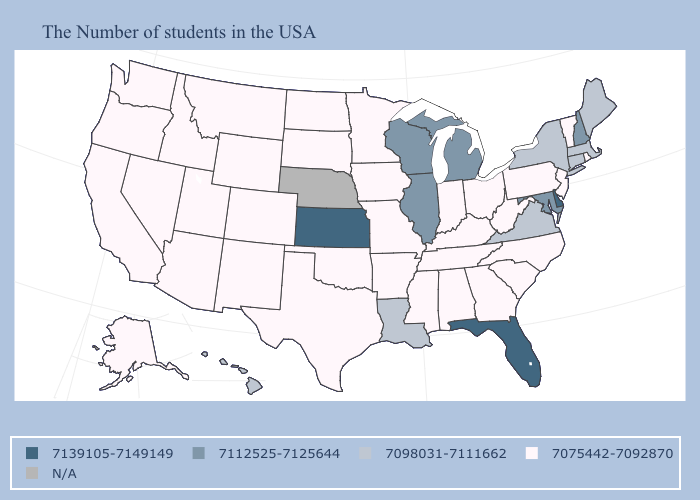Does the first symbol in the legend represent the smallest category?
Give a very brief answer. No. What is the lowest value in states that border Wyoming?
Write a very short answer. 7075442-7092870. Name the states that have a value in the range 7112525-7125644?
Quick response, please. New Hampshire, Maryland, Michigan, Wisconsin, Illinois. Does Iowa have the lowest value in the MidWest?
Short answer required. Yes. What is the lowest value in the USA?
Keep it brief. 7075442-7092870. What is the lowest value in states that border Oregon?
Keep it brief. 7075442-7092870. What is the highest value in the South ?
Short answer required. 7139105-7149149. Name the states that have a value in the range 7139105-7149149?
Quick response, please. Delaware, Florida, Kansas. Name the states that have a value in the range N/A?
Answer briefly. Nebraska. What is the value of Indiana?
Write a very short answer. 7075442-7092870. What is the highest value in states that border Minnesota?
Keep it brief. 7112525-7125644. Which states have the lowest value in the USA?
Write a very short answer. Rhode Island, Vermont, New Jersey, Pennsylvania, North Carolina, South Carolina, West Virginia, Ohio, Georgia, Kentucky, Indiana, Alabama, Tennessee, Mississippi, Missouri, Arkansas, Minnesota, Iowa, Oklahoma, Texas, South Dakota, North Dakota, Wyoming, Colorado, New Mexico, Utah, Montana, Arizona, Idaho, Nevada, California, Washington, Oregon, Alaska. Does the first symbol in the legend represent the smallest category?
Write a very short answer. No. Which states hav the highest value in the South?
Quick response, please. Delaware, Florida. Does the first symbol in the legend represent the smallest category?
Be succinct. No. 